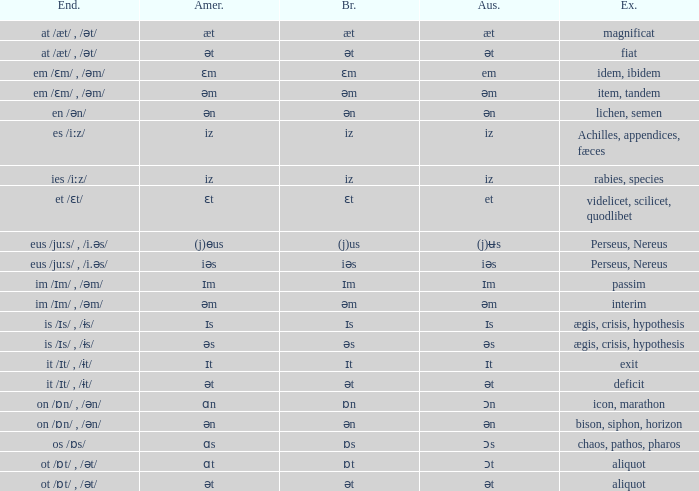Which Examples has Australian of əm? Item, tandem, interim. 